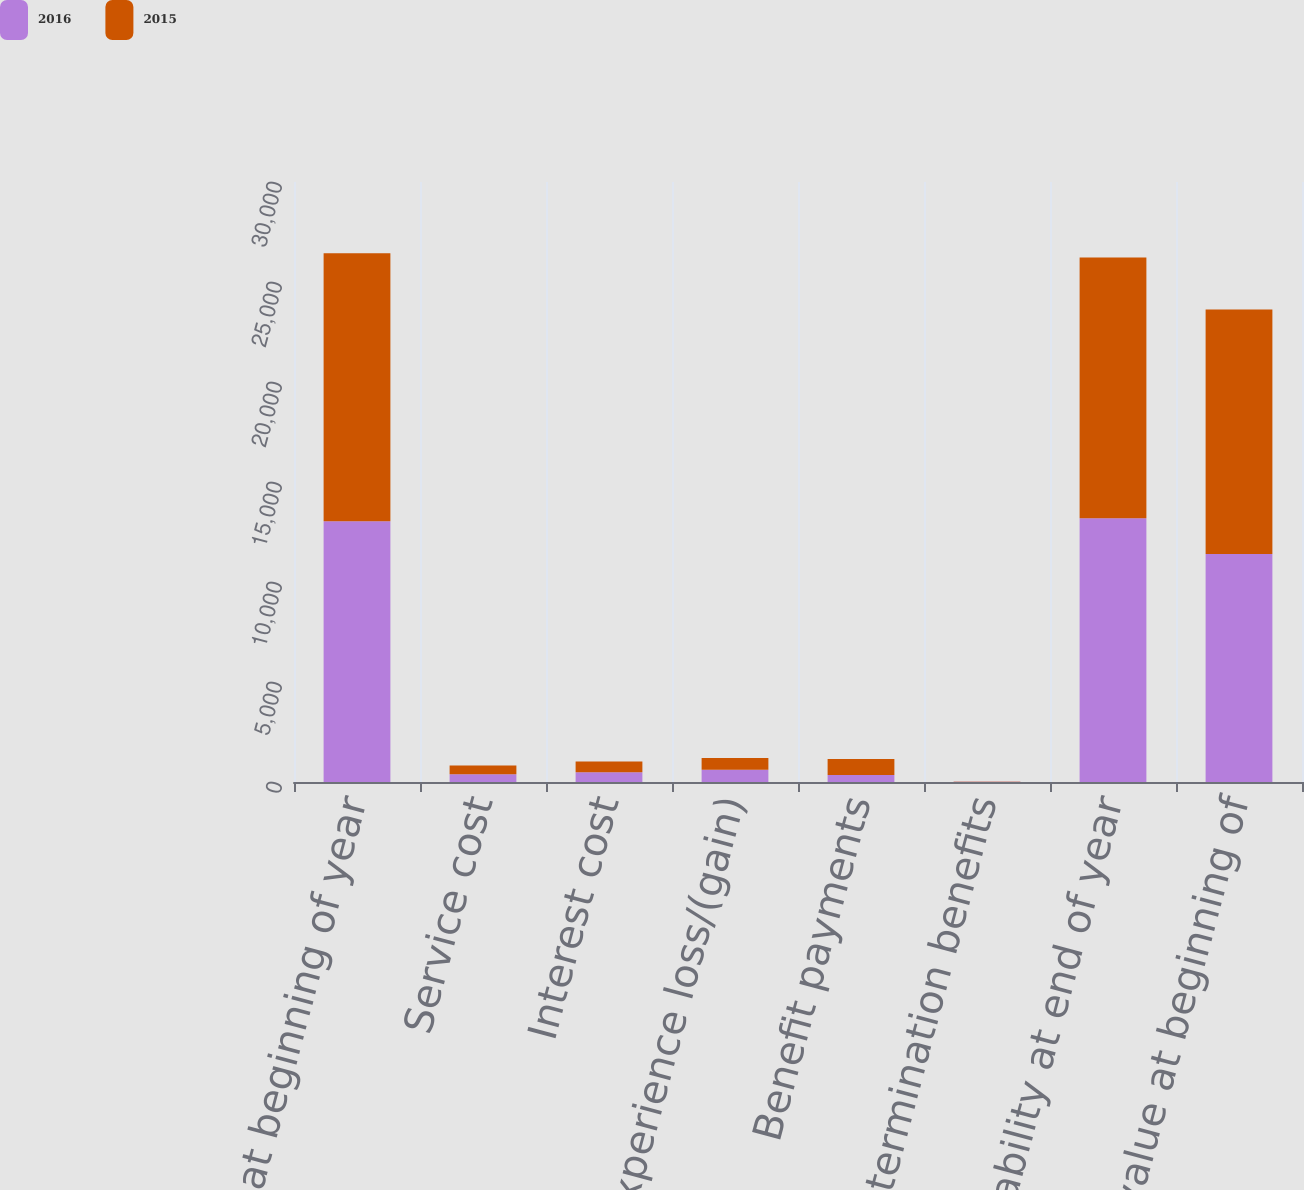<chart> <loc_0><loc_0><loc_500><loc_500><stacked_bar_chart><ecel><fcel>Liability at beginning of year<fcel>Service cost<fcel>Interest cost<fcel>Experience loss/(gain)<fcel>Benefit payments<fcel>Special termination benefits<fcel>Liability at end of year<fcel>Fair value at beginning of<nl><fcel>2016<fcel>13033<fcel>393<fcel>484<fcel>614<fcel>347<fcel>11<fcel>13192<fcel>11397<nl><fcel>2015<fcel>13409<fcel>435<fcel>546<fcel>583<fcel>808<fcel>18<fcel>13033<fcel>12224<nl></chart> 